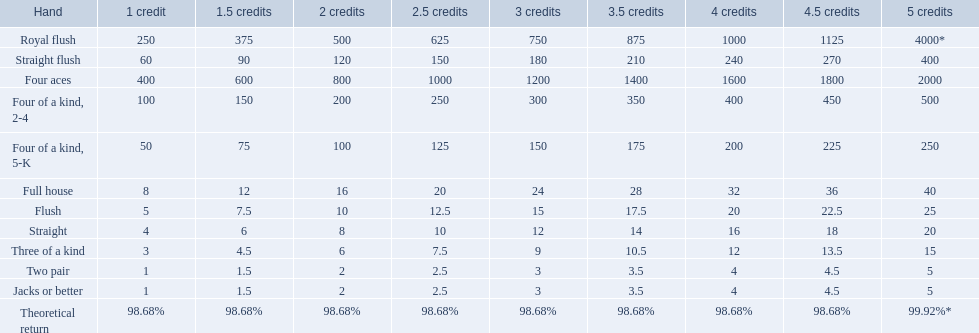What are the top 5 best types of hand for winning? Royal flush, Straight flush, Four aces, Four of a kind, 2-4, Four of a kind, 5-K. Between those 5, which of those hands are four of a kind? Four of a kind, 2-4, Four of a kind, 5-K. Of those 2 hands, which is the best kind of four of a kind for winning? Four of a kind, 2-4. 